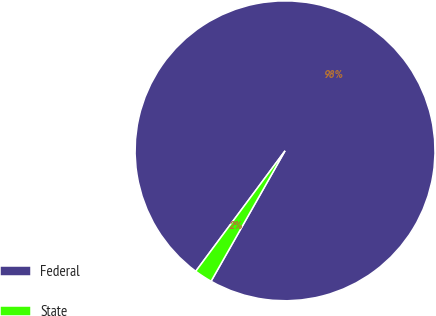<chart> <loc_0><loc_0><loc_500><loc_500><pie_chart><fcel>Federal<fcel>State<nl><fcel>98.06%<fcel>1.94%<nl></chart> 